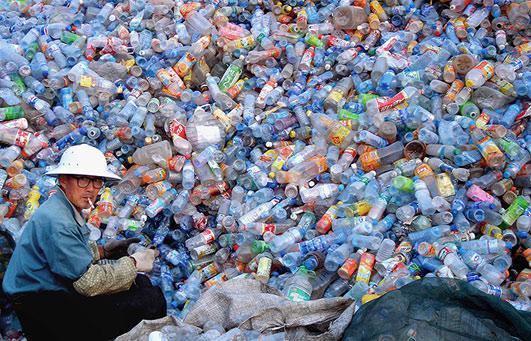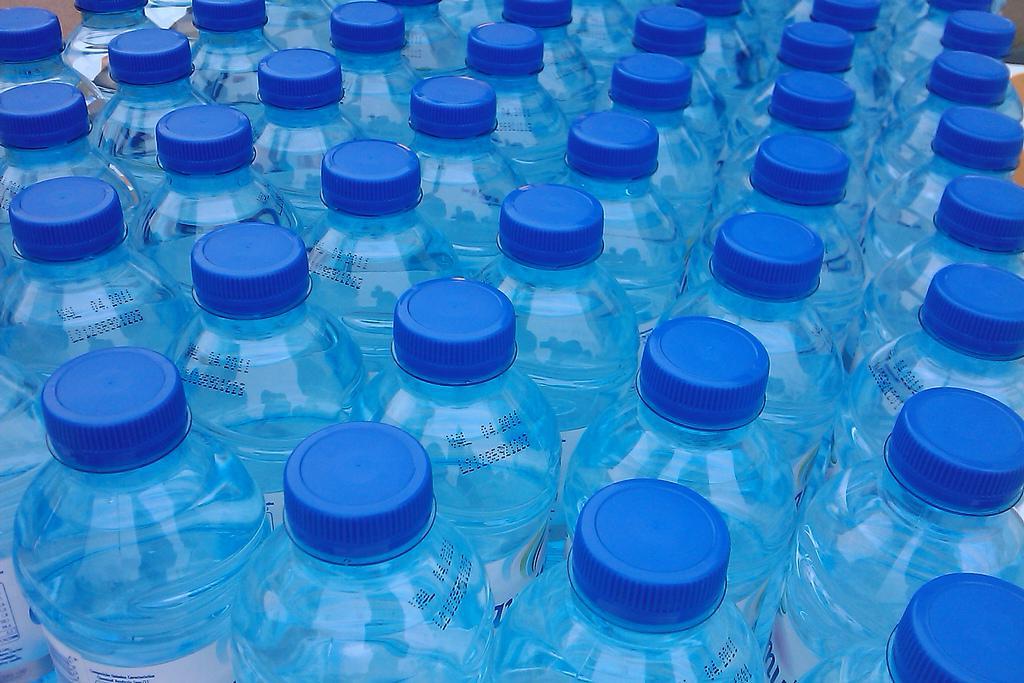The first image is the image on the left, the second image is the image on the right. Evaluate the accuracy of this statement regarding the images: "the bottles in the image on the right have white caps.". Is it true? Answer yes or no. No. The first image is the image on the left, the second image is the image on the right. Assess this claim about the two images: "The bottles have white caps in at least one of the images.". Correct or not? Answer yes or no. No. 